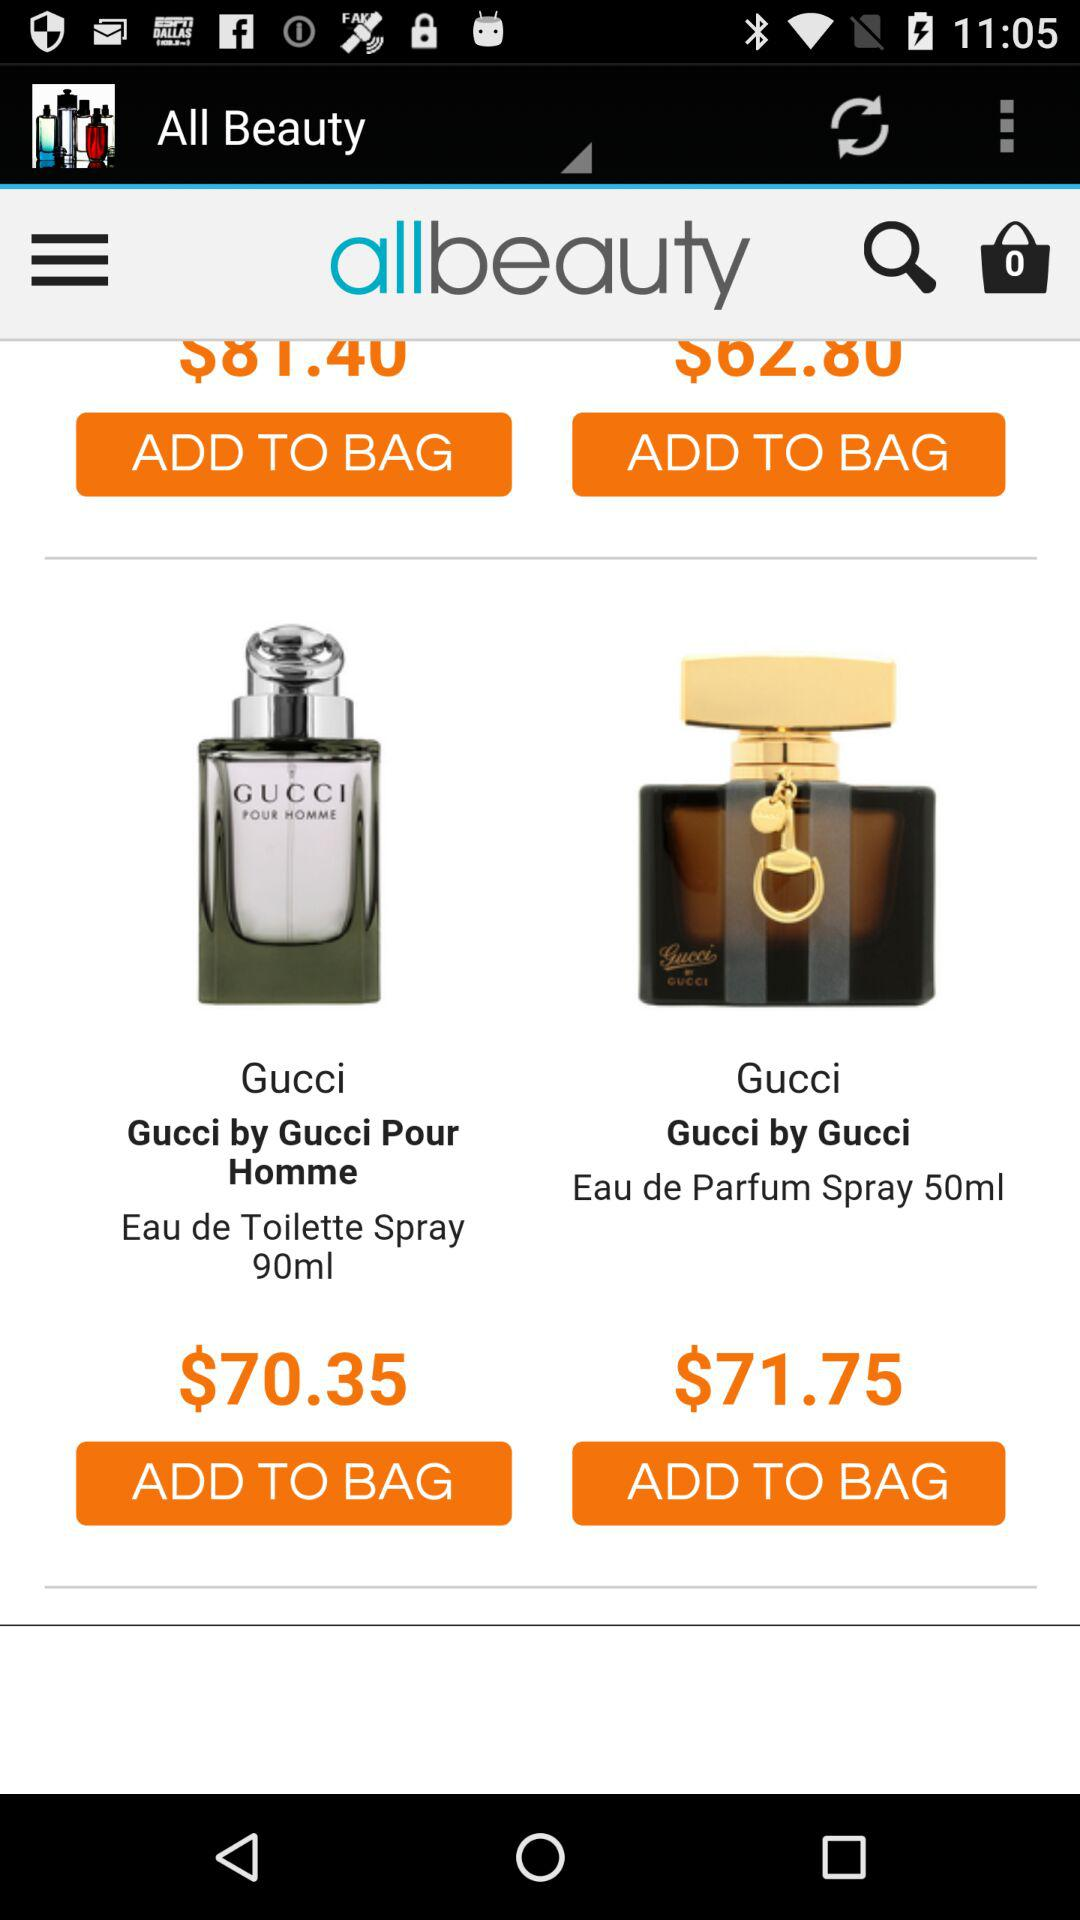Which item has a price of $70.35? The item that has a price of $70.35 is "Gucci by Gucci Pour Homme". 